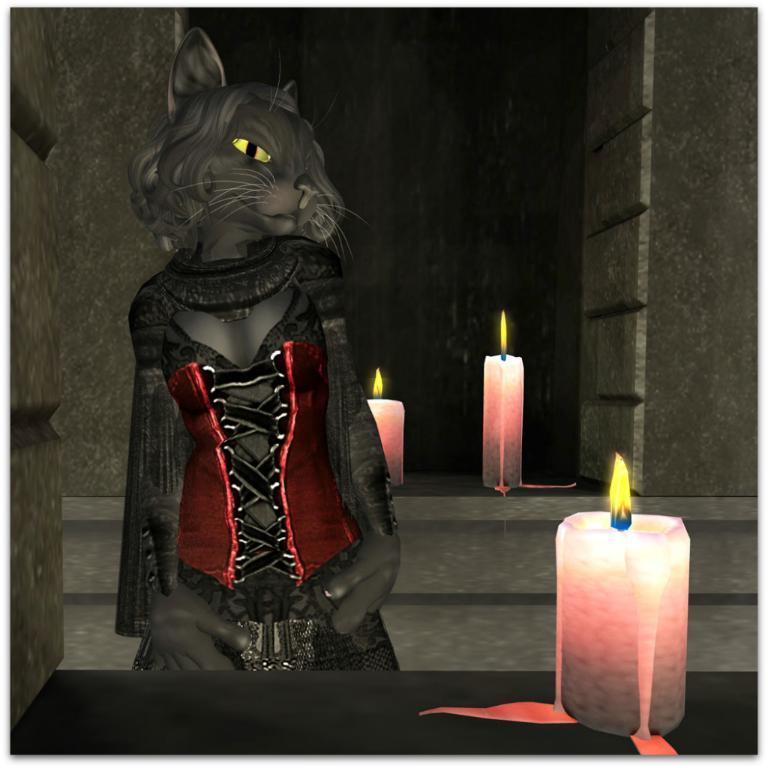Could you give a brief overview of what you see in this image? In this image, we can see a cat cartoon and there are candles. 